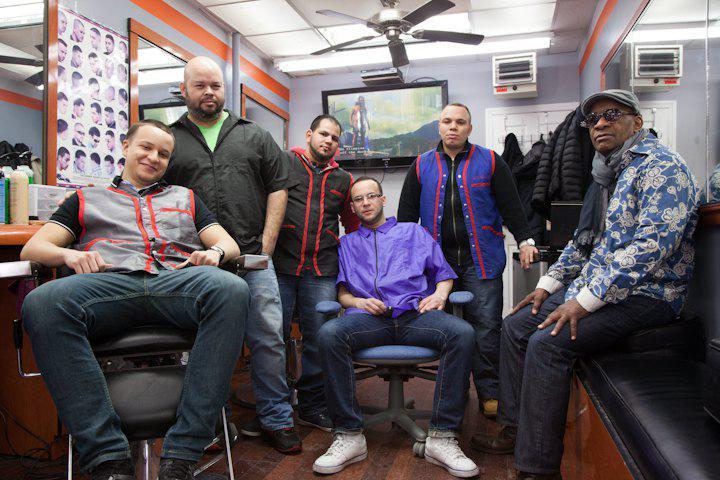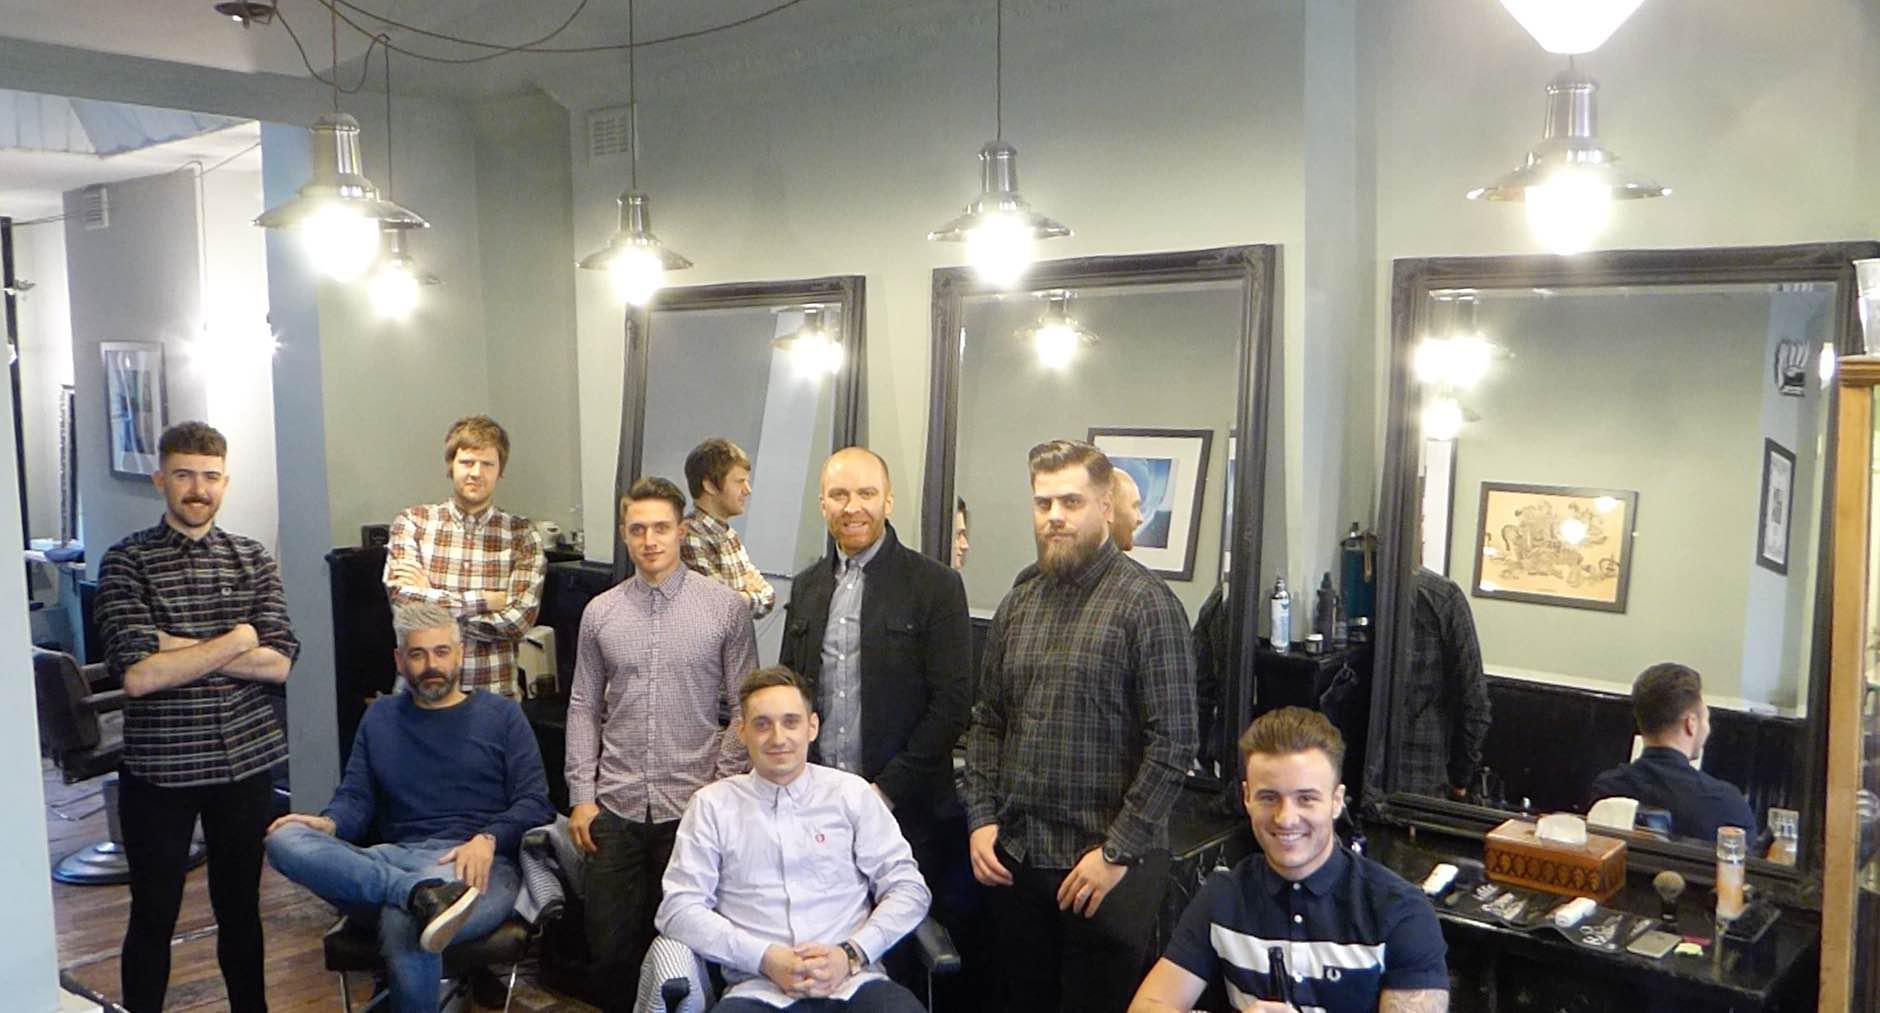The first image is the image on the left, the second image is the image on the right. Considering the images on both sides, is "Nobody is getting a haircut in the left image, but someone is in the right image." valid? Answer yes or no. No. The first image is the image on the left, the second image is the image on the right. Evaluate the accuracy of this statement regarding the images: "People are getting their haircut in exactly one image.". Is it true? Answer yes or no. No. 